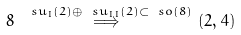<formula> <loc_0><loc_0><loc_500><loc_500>8 \, \stackrel { \ s u _ { I } ( 2 ) \oplus \ s u _ { I I } ( 2 ) \subset \ s o ( 8 ) } { \Longrightarrow } \, ( 2 , 4 )</formula> 